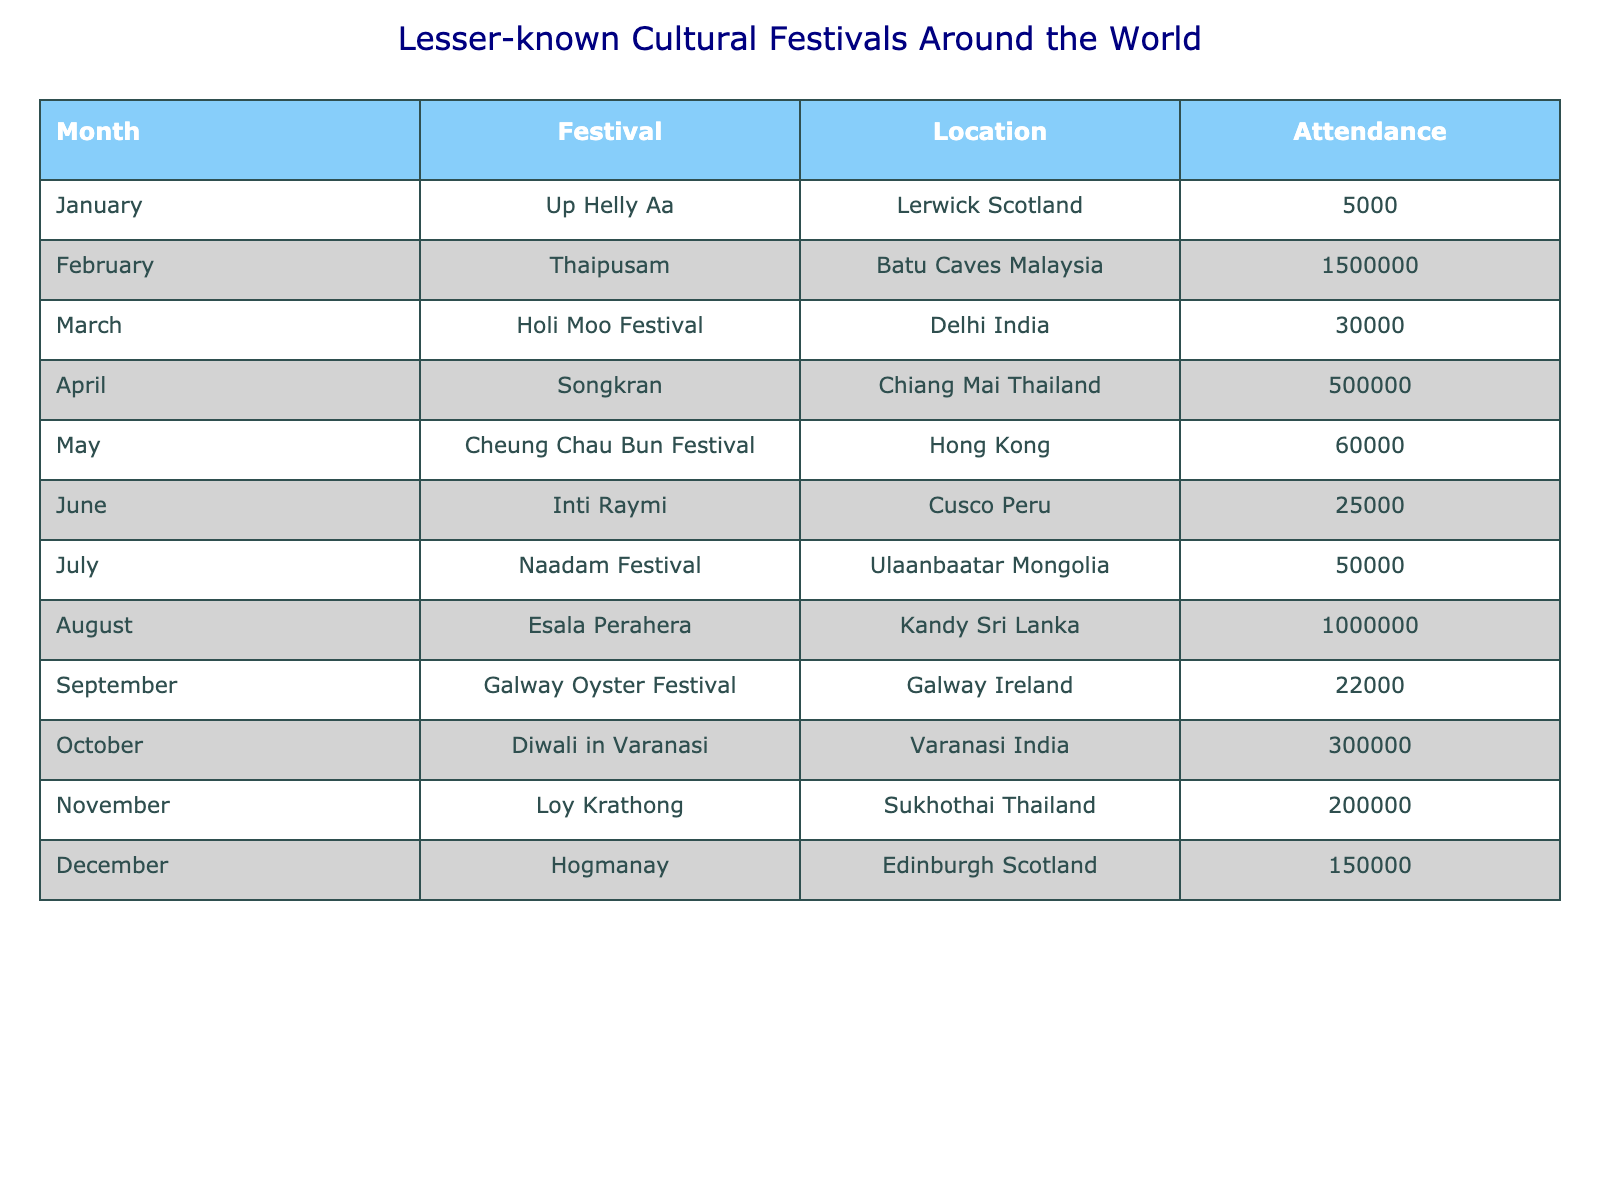What festival has the highest attendance? The table shows that Thaipusam in Batu Caves, Malaysia has the highest attendance figure at 1,500,000.
Answer: Thaipusam How many people attended the Diwali festival in Varanasi, India? The table lists the attendance for Diwali in Varanasi, India as 300,000.
Answer: 300,000 What month features the Esala Perahera festival? According to the table, the Esala Perahera festival is celebrated in August.
Answer: August What is the average attendance of festivals held in January and December? The attendance for Up Helly Aa in January is 5,000, and for Hogmanay in December is 150,000. The average is (5,000 + 150,000) / 2 = 77,500.
Answer: 77,500 Are there any festivals in the table with an attendance of over 1 million? By checking the attendance figures, the answer is no since the highest attendance is 1,500,000 for Thaipusam, and it is the only festival over 1 million.
Answer: Yes Which festival in September had the lowest attendance? The table shows that the Galway Oyster Festival in September had the lowest attendance at 22,000 among the listed festivals.
Answer: Galway Oyster Festival How does the attendance of the Songkran festival compare to that of the Holi Moo Festival? The attendance for Songkran in April is 500,000, while the Holi Moo Festival in March has 30,000. Thus, Songkran has much higher attendance compared to Holi Moo.
Answer: Songkran has higher attendance What is the total attendance of festivals in March and April combined? The attendance for Holi Moo Festival in March is 30,000 and Songkran in April is 500,000. The total is 30,000 + 500,000 = 530,000.
Answer: 530,000 Which festival has a similar attendance size to the Cheung Chau Bun Festival? The table shows that both the Naadam Festival in July and Cheung Chau Bun Festival in May have similar attendance sizes, with Naadam having 50,000 and Cheung Chau featuring 60,000.
Answer: Cheung Chau Bun Festival 